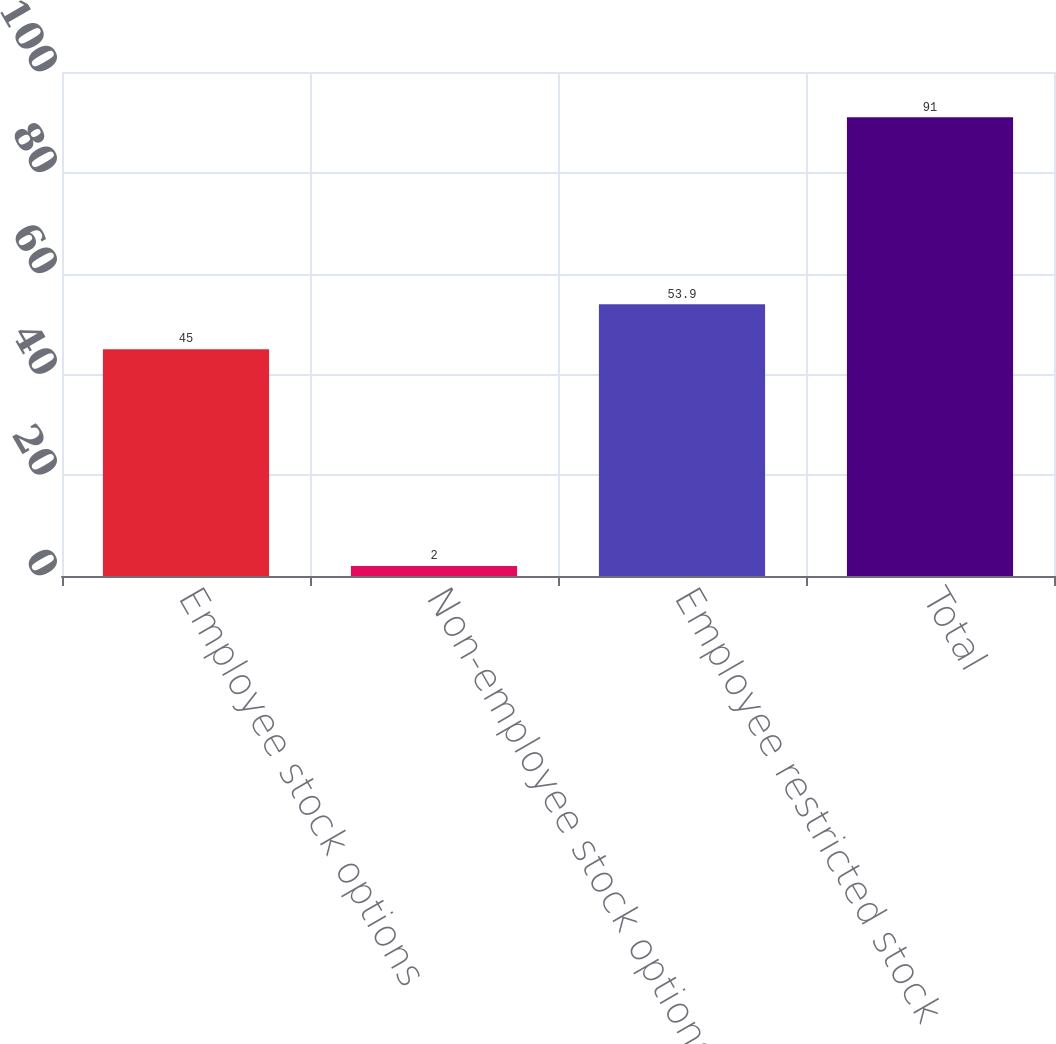<chart> <loc_0><loc_0><loc_500><loc_500><bar_chart><fcel>Employee stock options<fcel>Non-employee stock options<fcel>Employee restricted stock<fcel>Total<nl><fcel>45<fcel>2<fcel>53.9<fcel>91<nl></chart> 